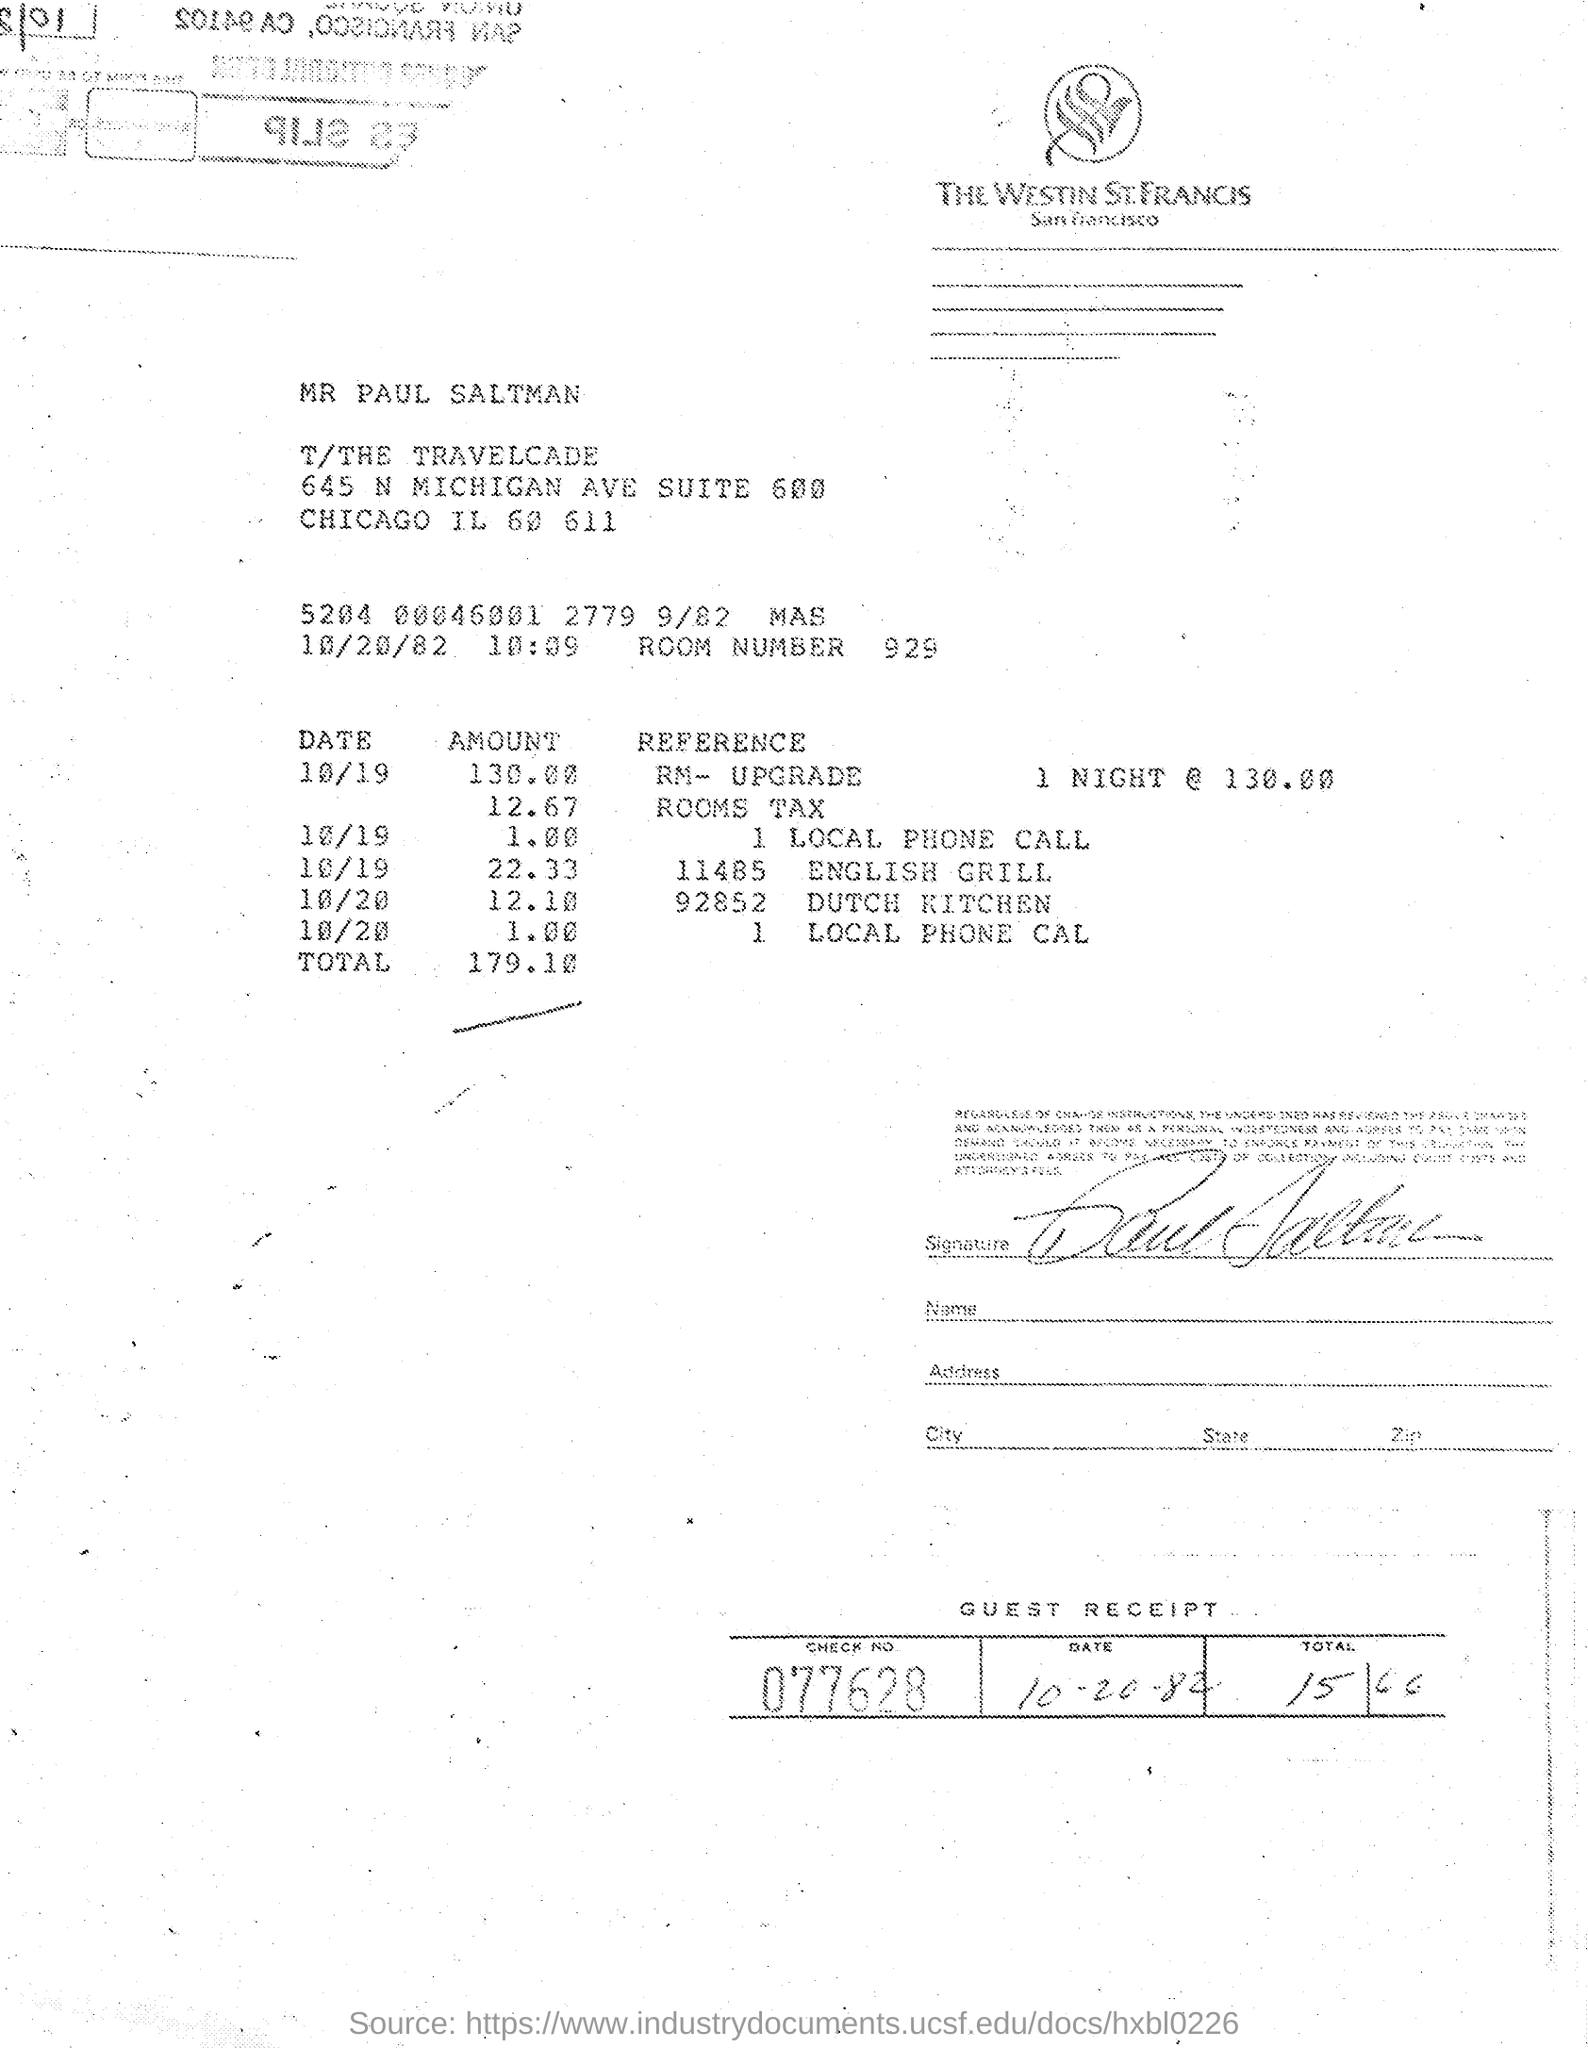What is the Check No. mentioned in the Guest Receipt?
Offer a very short reply. 077628. 